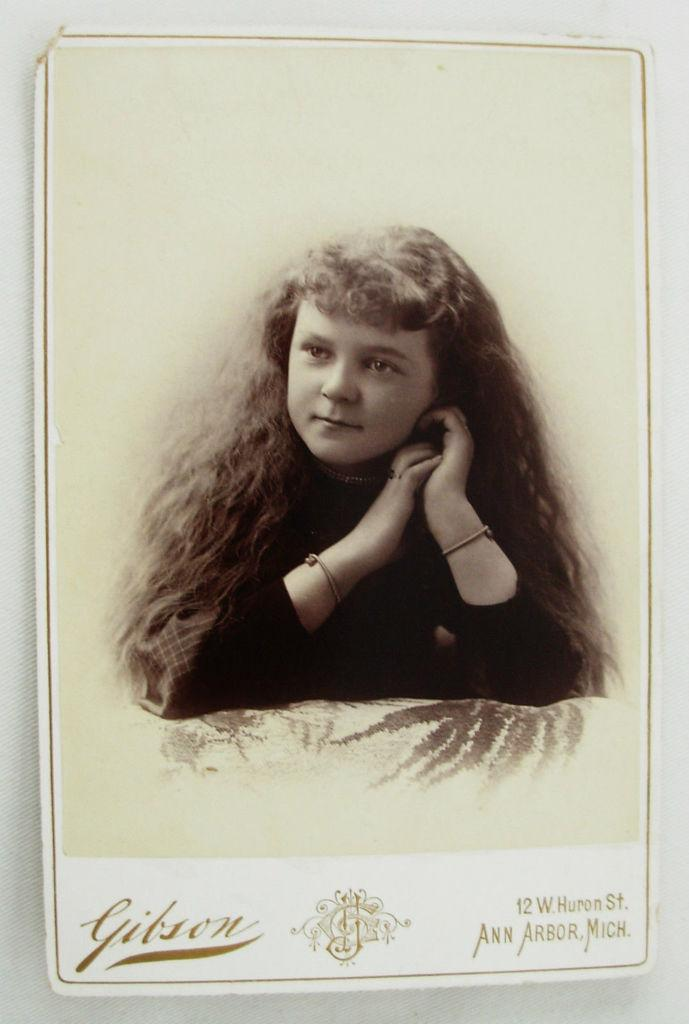What is the main subject of the image? The main subject of the image is a photograph of a small girl. What is the girl doing in the photograph? The girl is giving a pose to the camera. Is there any text visible on the image? Yes, the text "Gibson" is written on the front bottom side of the image. What advice does the achiever give in the image? There is no achiever present in the image, nor is there any advice being given. 